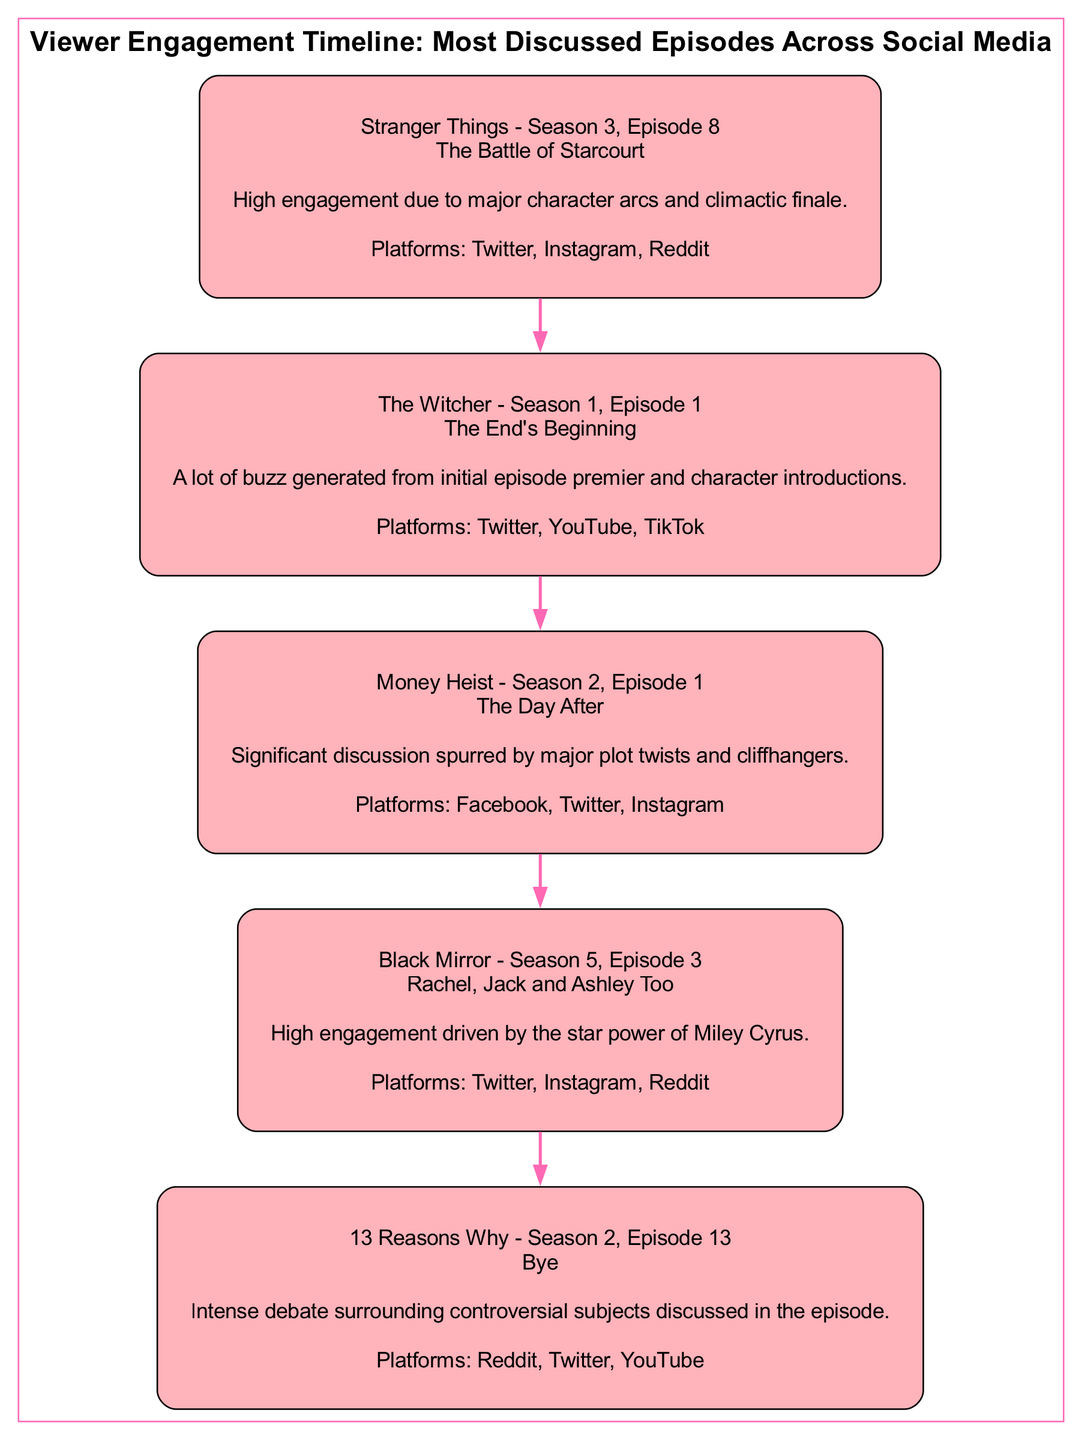what is the most discussed episode from Stranger Things? The diagram shows that "Stranger Things - Season 3, Episode 8" is listed as one of the most discussed episodes, specifically titled "The Battle of Starcourt."
Answer: The Battle of Starcourt how many platforms did The Witcher - Season 1, Episode 1 engage with? According to the diagram, "The Witcher - Season 1, Episode 1" engaged with three platforms, which are Twitter, YouTube, and TikTok.
Answer: 3 which episode had significant discussion spurred by major plot twists? The diagram indicates that "Money Heist - Season 2, Episode 1," titled "The Day After," was noted for significant discussion due to major plot twists.
Answer: The Day After which episode is associated with Miley Cyrus? The diagram identifies "Black Mirror - Season 5, Episode 3," titled "Rachel, Jack and Ashley Too," as having high engagement driven by the star power of Miley Cyrus.
Answer: Rachel, Jack and Ashley Too what is the main reason for discussion surrounding 13 Reasons Why - Season 2, Episode 13? The diagram explains that "13 Reasons Why - Season 2, Episode 13," titled "Bye," sparked intense debate regarding controversial subjects discussed in the episode.
Answer: Controversial subjects which two platforms were mentioned for Stranger Things - Season 3, Episode 8? The diagram lists three platforms where "Stranger Things - Season 3, Episode 8" was discussed, and specifically mentions Twitter and Instagram as two of those platforms.
Answer: Twitter, Instagram how many episodes are illustrated in the diagram? The diagram includes five blocks, each representing a different episode, indicating that there are five episodes illustrated in total.
Answer: 5 which episode had the least number of platforms listed? Upon examining the platforms associated with each episode in the diagram, "The Witcher - Season 1, Episode 1" has the least number of platforms, which is three.
Answer: The End's Beginning what was a common platform among all episodes mentioned in the diagram? The diagram shows that Twitter appears as a common platform among multiple episodes, indicating it was used for engagement across different shows.
Answer: Twitter which episode's engagement was mainly due to a series premiere? From the diagram, it is clear that the engagement for "The Witcher - Season 1, Episode 1," titled "The End's Beginning," was largely due to the buzz generated from the series premiere.
Answer: The End's Beginning 